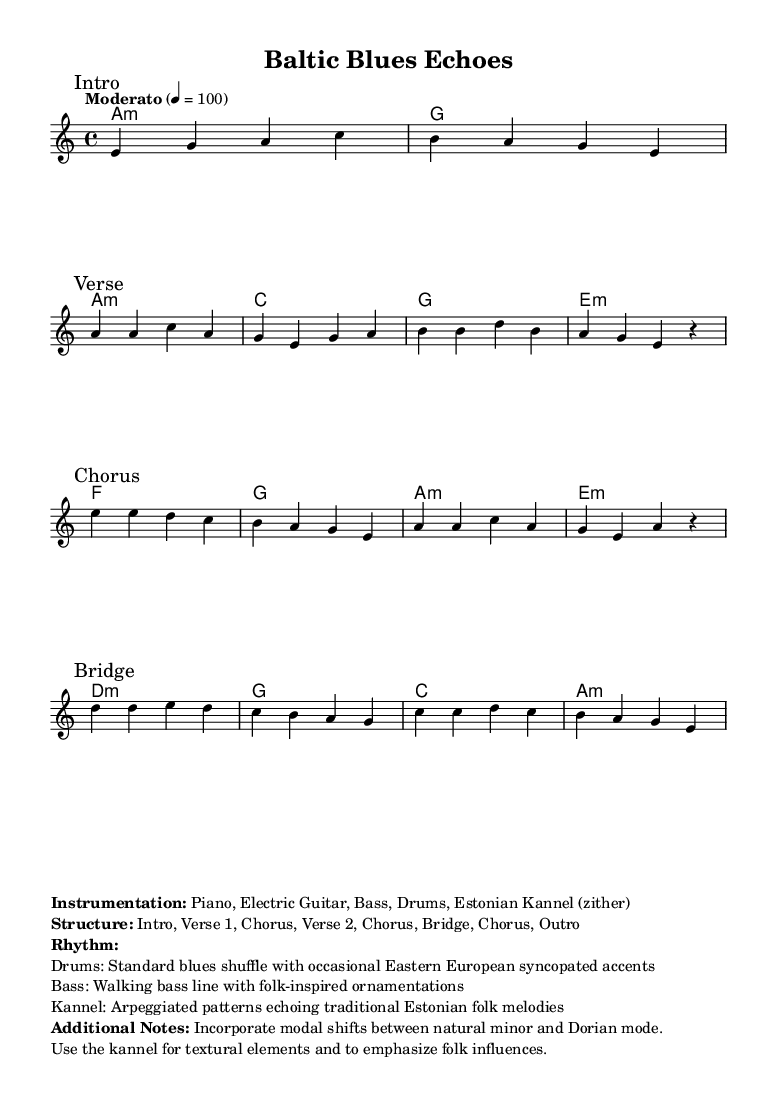What is the key signature of this music? The key signature is A minor, which has no sharps or flats.
Answer: A minor What is the time signature of this music? The time signature is indicated as 4/4, which means there are four beats per measure.
Answer: 4/4 What is the tempo of this composition? The tempo is marked as "Moderato" with a metronome marking of 100 beats per minute, suggesting a moderate speed.
Answer: Moderato, 100 What instruments are used in this piece? The instrumentation listed includes Piano, Electric Guitar, Bass, Drums, and Estonian Kannel (zither).
Answer: Piano, Electric Guitar, Bass, Drums, Estonian Kannel How many sections are there in the structure of the music? The structure has a total of 8 sections: Intro, Verse 1, Chorus, Verse 2, Chorus, Bridge, Chorus, and Outro.
Answer: 8 What kind of rhythm is used for the drums? The drums follow a standard blues shuffle rhythm, while also incorporating Eastern European syncopated accents to enhance the fusion style.
Answer: Standard blues shuffle What modal shifts are incorporated in this composition? The composition includes modal shifts between natural minor and Dorian mode, which provides a varied harmonic texture and influences the sound characteristic of the piece.
Answer: Natural minor and Dorian mode 